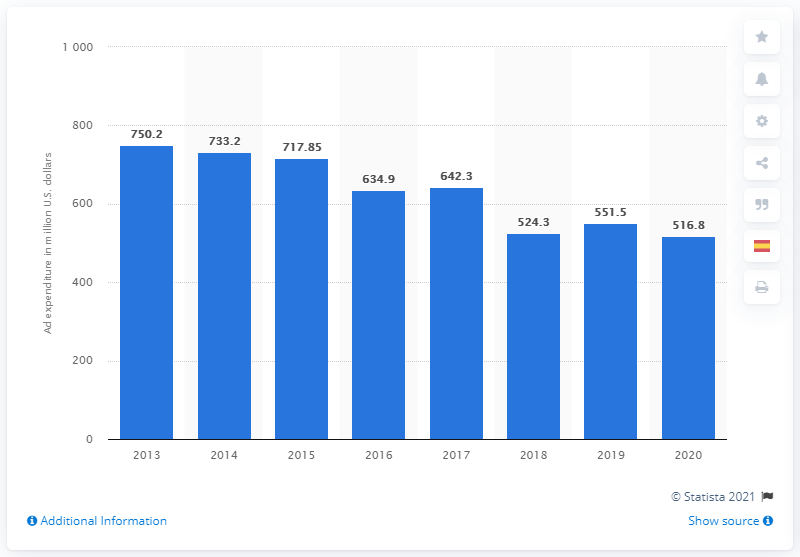Specify some key components in this picture. Mattel spent $516.8 million on advertising and promotion in the United States in 2020. 